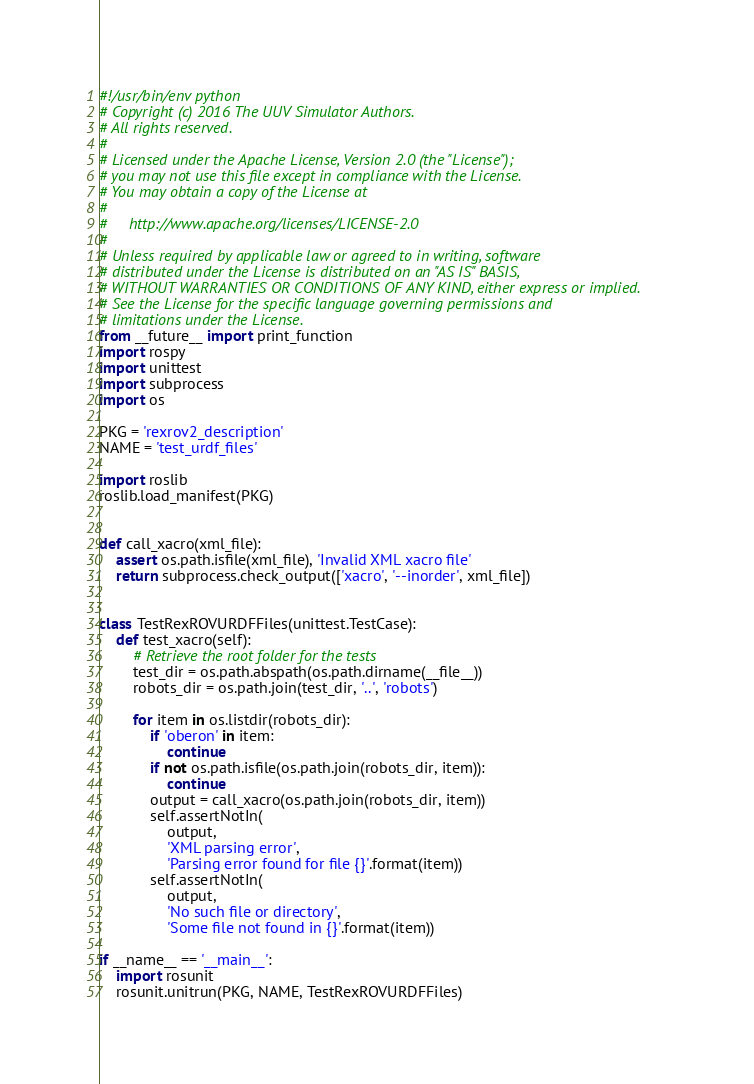<code> <loc_0><loc_0><loc_500><loc_500><_Python_>#!/usr/bin/env python
# Copyright (c) 2016 The UUV Simulator Authors.
# All rights reserved.
#
# Licensed under the Apache License, Version 2.0 (the "License");
# you may not use this file except in compliance with the License.
# You may obtain a copy of the License at
#
#     http://www.apache.org/licenses/LICENSE-2.0
#
# Unless required by applicable law or agreed to in writing, software
# distributed under the License is distributed on an "AS IS" BASIS,
# WITHOUT WARRANTIES OR CONDITIONS OF ANY KIND, either express or implied.
# See the License for the specific language governing permissions and
# limitations under the License.
from __future__ import print_function
import rospy
import unittest
import subprocess
import os

PKG = 'rexrov2_description'
NAME = 'test_urdf_files'

import roslib
roslib.load_manifest(PKG)


def call_xacro(xml_file):
    assert os.path.isfile(xml_file), 'Invalid XML xacro file'
    return subprocess.check_output(['xacro', '--inorder', xml_file])


class TestRexROVURDFFiles(unittest.TestCase):
    def test_xacro(self):
        # Retrieve the root folder for the tests
        test_dir = os.path.abspath(os.path.dirname(__file__))
        robots_dir = os.path.join(test_dir, '..', 'robots')

        for item in os.listdir(robots_dir):
            if 'oberon' in item:
                continue
            if not os.path.isfile(os.path.join(robots_dir, item)):
                continue
            output = call_xacro(os.path.join(robots_dir, item))
            self.assertNotIn(
                output, 
                'XML parsing error',
                'Parsing error found for file {}'.format(item))
            self.assertNotIn(
                output, 
                'No such file or directory', 
                'Some file not found in {}'.format(item))

if __name__ == '__main__':
    import rosunit
    rosunit.unitrun(PKG, NAME, TestRexROVURDFFiles)



</code> 